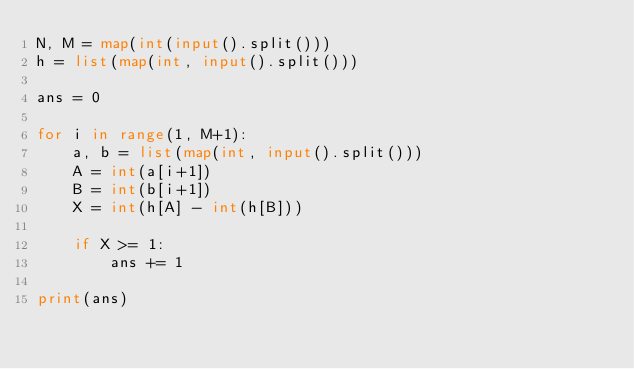<code> <loc_0><loc_0><loc_500><loc_500><_Python_>N, M = map(int(input().split()))
h = list(map(int, input().split()))

ans = 0

for i in range(1, M+1):
    a, b = list(map(int, input().split()))
    A = int(a[i+1])
    B = int(b[i+1])
    X = int(h[A] - int(h[B]))
    
    if X >= 1:
        ans += 1

print(ans)</code> 